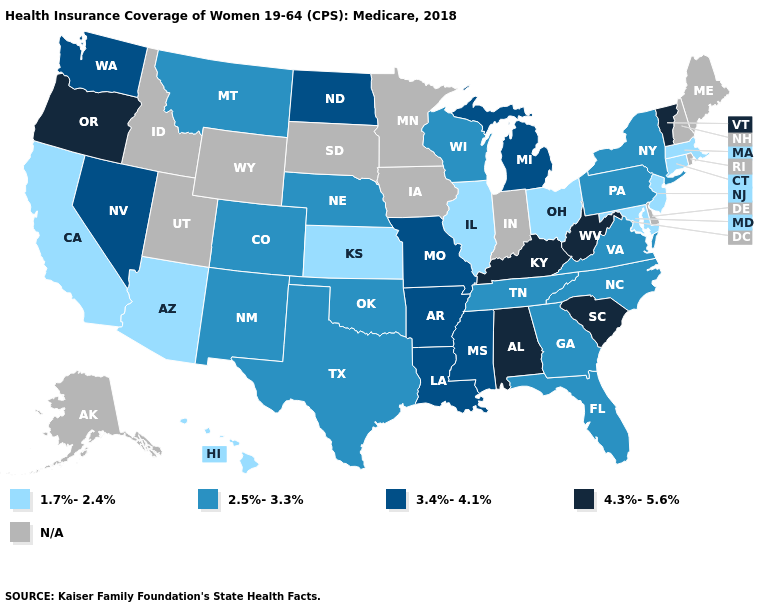What is the value of Michigan?
Answer briefly. 3.4%-4.1%. Does Louisiana have the lowest value in the USA?
Quick response, please. No. Among the states that border Oklahoma , does Colorado have the lowest value?
Concise answer only. No. What is the lowest value in states that border North Carolina?
Give a very brief answer. 2.5%-3.3%. Does Oregon have the highest value in the West?
Keep it brief. Yes. What is the lowest value in the West?
Concise answer only. 1.7%-2.4%. Which states have the highest value in the USA?
Give a very brief answer. Alabama, Kentucky, Oregon, South Carolina, Vermont, West Virginia. What is the value of Ohio?
Keep it brief. 1.7%-2.4%. What is the value of Maryland?
Answer briefly. 1.7%-2.4%. What is the lowest value in states that border Idaho?
Concise answer only. 2.5%-3.3%. What is the value of Kentucky?
Write a very short answer. 4.3%-5.6%. Among the states that border North Dakota , which have the lowest value?
Concise answer only. Montana. Name the states that have a value in the range 4.3%-5.6%?
Short answer required. Alabama, Kentucky, Oregon, South Carolina, Vermont, West Virginia. What is the highest value in the USA?
Keep it brief. 4.3%-5.6%. Which states have the lowest value in the USA?
Be succinct. Arizona, California, Connecticut, Hawaii, Illinois, Kansas, Maryland, Massachusetts, New Jersey, Ohio. 